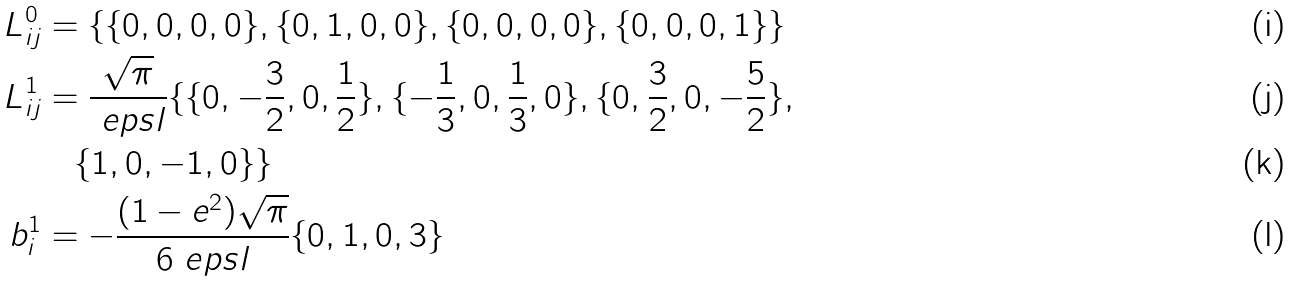Convert formula to latex. <formula><loc_0><loc_0><loc_500><loc_500>L ^ { 0 } _ { i j } & = \{ \{ 0 , 0 , 0 , 0 \} , \{ 0 , 1 , 0 , 0 \} , \{ 0 , 0 , 0 , 0 \} , \{ 0 , 0 , 0 , 1 \} \} \\ L ^ { 1 } _ { i j } & = \frac { \sqrt { \pi } } { \ e p s l } \{ \{ 0 , - { \frac { 3 } { 2 } } , 0 , { \frac { 1 } { 2 } } \} , \{ - { \frac { 1 } { 3 } } , 0 , { \frac { 1 } { 3 } } , 0 \} , \{ 0 , { \frac { 3 } { 2 } } , 0 , - { \frac { 5 } { 2 } } \} , \\ & \quad \{ 1 , 0 , - 1 , 0 \} \} \\ b ^ { 1 } _ { i } & = - \frac { ( 1 - e ^ { 2 } ) \sqrt { \pi } } { 6 \ e p s l } \{ 0 , 1 , 0 , 3 \}</formula> 